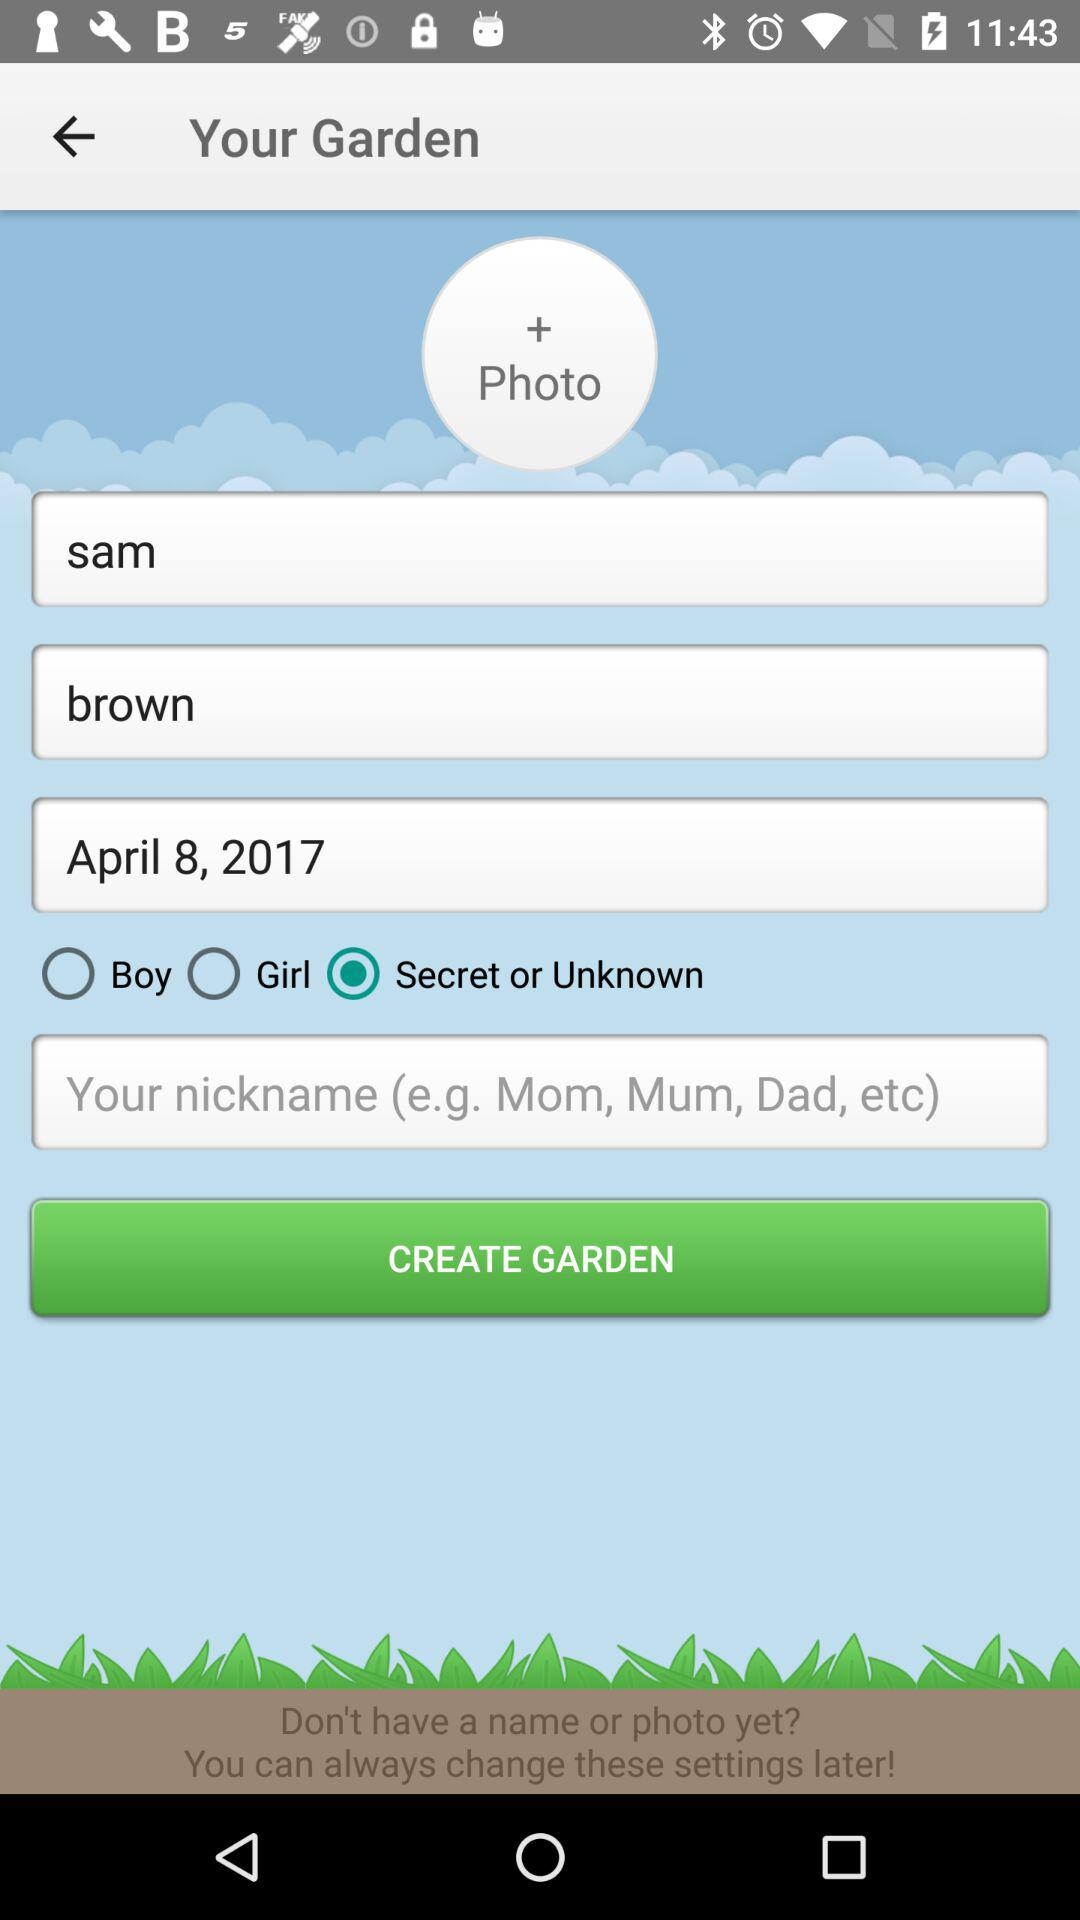What's the selected gender? The selected option for gender is "Secret or Unknown". 